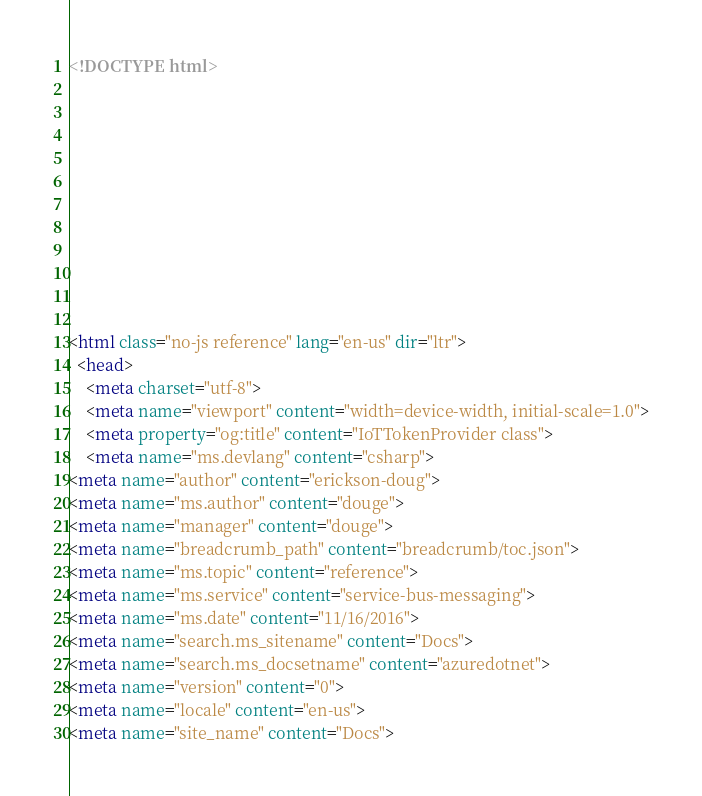<code> <loc_0><loc_0><loc_500><loc_500><_HTML_><!DOCTYPE html>



  


  


  

<html class="no-js reference" lang="en-us" dir="ltr">
  <head>
    <meta charset="utf-8">
    <meta name="viewport" content="width=device-width, initial-scale=1.0">
    <meta property="og:title" content="IoTTokenProvider class">
    <meta name="ms.devlang" content="csharp">
<meta name="author" content="erickson-doug">
<meta name="ms.author" content="douge">
<meta name="manager" content="douge">
<meta name="breadcrumb_path" content="breadcrumb/toc.json">
<meta name="ms.topic" content="reference">
<meta name="ms.service" content="service-bus-messaging">
<meta name="ms.date" content="11/16/2016">
<meta name="search.ms_sitename" content="Docs">
<meta name="search.ms_docsetname" content="azuredotnet">
<meta name="version" content="0">
<meta name="locale" content="en-us">
<meta name="site_name" content="Docs"></code> 